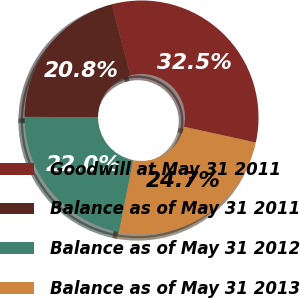<chart> <loc_0><loc_0><loc_500><loc_500><pie_chart><fcel>Goodwill at May 31 2011<fcel>Balance as of May 31 2011<fcel>Balance as of May 31 2012<fcel>Balance as of May 31 2013<nl><fcel>32.54%<fcel>20.82%<fcel>21.99%<fcel>24.66%<nl></chart> 